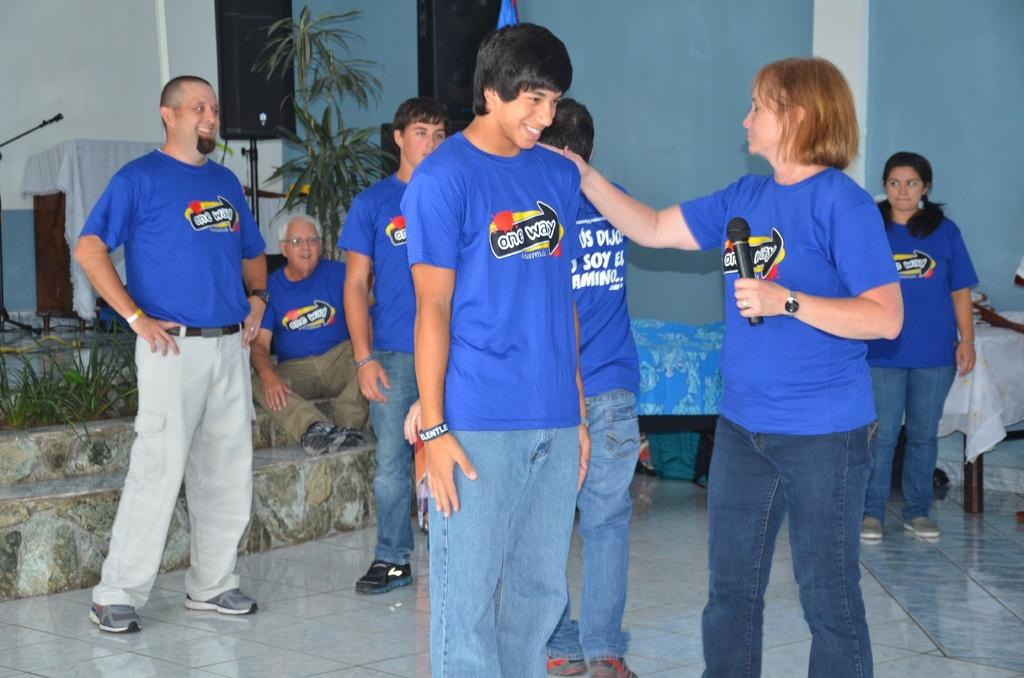<image>
Write a terse but informative summary of the picture. A group of people are wearing blue shirts that say one way. 